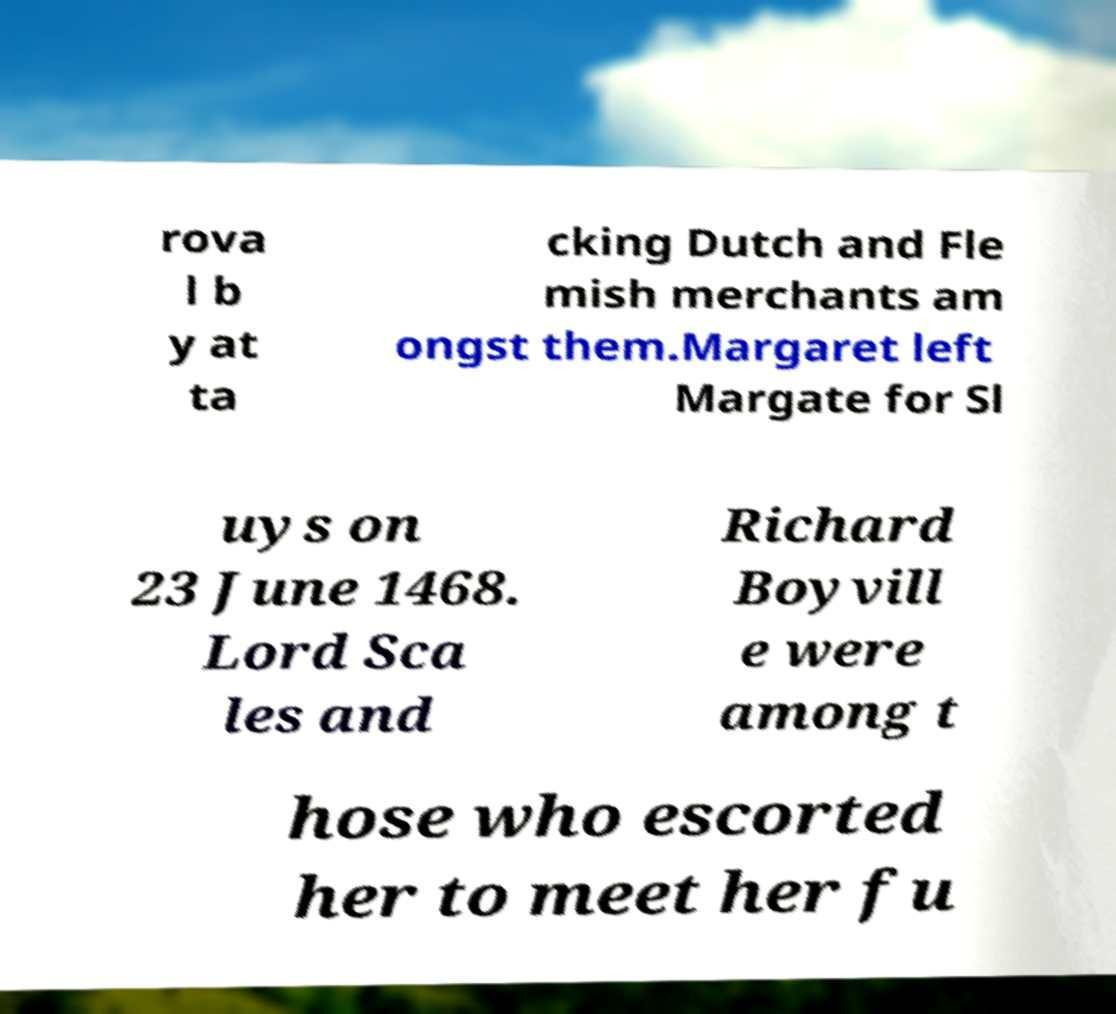Could you assist in decoding the text presented in this image and type it out clearly? rova l b y at ta cking Dutch and Fle mish merchants am ongst them.Margaret left Margate for Sl uys on 23 June 1468. Lord Sca les and Richard Boyvill e were among t hose who escorted her to meet her fu 